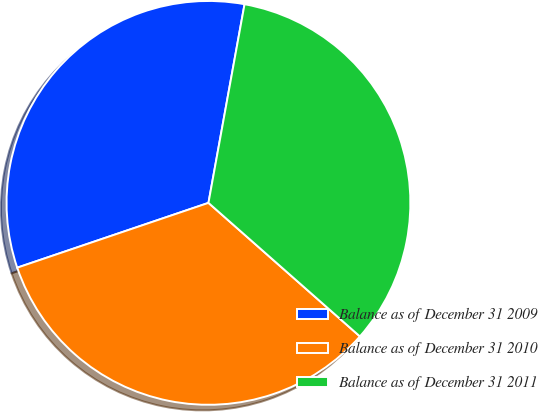Convert chart to OTSL. <chart><loc_0><loc_0><loc_500><loc_500><pie_chart><fcel>Balance as of December 31 2009<fcel>Balance as of December 31 2010<fcel>Balance as of December 31 2011<nl><fcel>33.06%<fcel>33.3%<fcel>33.64%<nl></chart> 